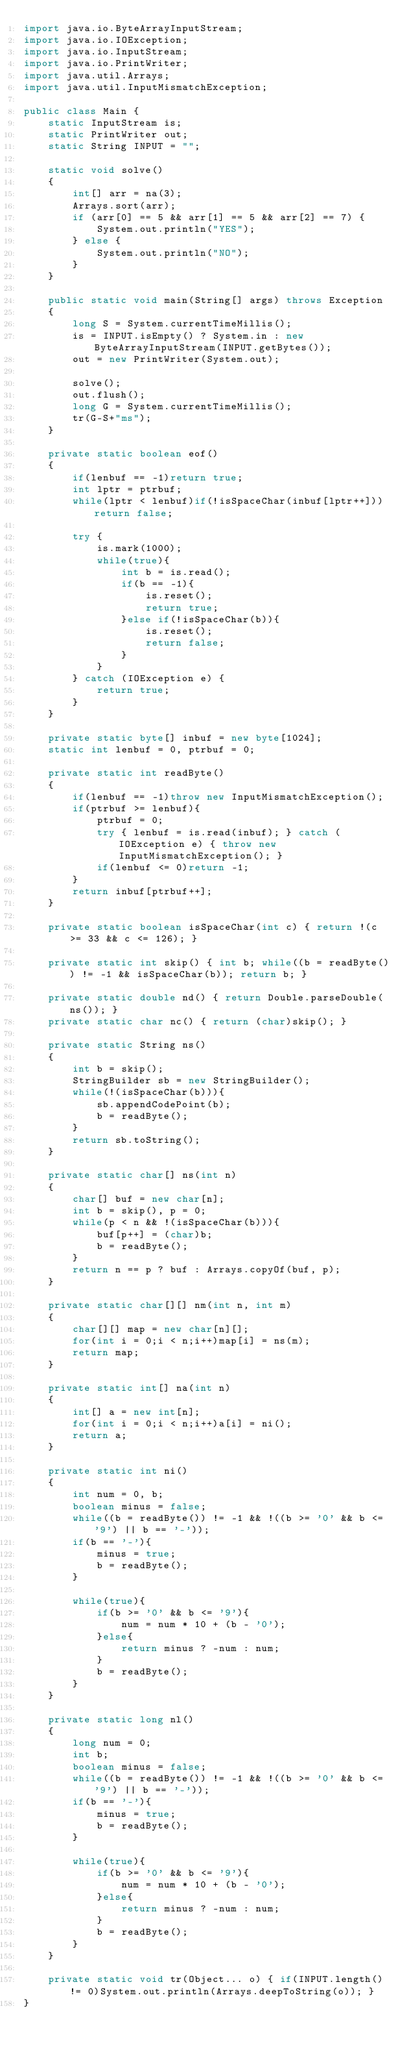Convert code to text. <code><loc_0><loc_0><loc_500><loc_500><_Java_>import java.io.ByteArrayInputStream;
import java.io.IOException;
import java.io.InputStream;
import java.io.PrintWriter;
import java.util.Arrays;
import java.util.InputMismatchException;

public class Main {
    static InputStream is;
    static PrintWriter out;
    static String INPUT = "";

    static void solve()
    {
        int[] arr = na(3);
        Arrays.sort(arr);
        if (arr[0] == 5 && arr[1] == 5 && arr[2] == 7) {
            System.out.println("YES");
        } else {
            System.out.println("NO");
        }
    }

    public static void main(String[] args) throws Exception
    {
        long S = System.currentTimeMillis();
        is = INPUT.isEmpty() ? System.in : new ByteArrayInputStream(INPUT.getBytes());
        out = new PrintWriter(System.out);

        solve();
        out.flush();
        long G = System.currentTimeMillis();
        tr(G-S+"ms");
    }

    private static boolean eof()
    {
        if(lenbuf == -1)return true;
        int lptr = ptrbuf;
        while(lptr < lenbuf)if(!isSpaceChar(inbuf[lptr++]))return false;

        try {
            is.mark(1000);
            while(true){
                int b = is.read();
                if(b == -1){
                    is.reset();
                    return true;
                }else if(!isSpaceChar(b)){
                    is.reset();
                    return false;
                }
            }
        } catch (IOException e) {
            return true;
        }
    }

    private static byte[] inbuf = new byte[1024];
    static int lenbuf = 0, ptrbuf = 0;

    private static int readByte()
    {
        if(lenbuf == -1)throw new InputMismatchException();
        if(ptrbuf >= lenbuf){
            ptrbuf = 0;
            try { lenbuf = is.read(inbuf); } catch (IOException e) { throw new InputMismatchException(); }
            if(lenbuf <= 0)return -1;
        }
        return inbuf[ptrbuf++];
    }

    private static boolean isSpaceChar(int c) { return !(c >= 33 && c <= 126); }

    private static int skip() { int b; while((b = readByte()) != -1 && isSpaceChar(b)); return b; }

    private static double nd() { return Double.parseDouble(ns()); }
    private static char nc() { return (char)skip(); }

    private static String ns()
    {
        int b = skip();
        StringBuilder sb = new StringBuilder();
        while(!(isSpaceChar(b))){
            sb.appendCodePoint(b);
            b = readByte();
        }
        return sb.toString();
    }

    private static char[] ns(int n)
    {
        char[] buf = new char[n];
        int b = skip(), p = 0;
        while(p < n && !(isSpaceChar(b))){
            buf[p++] = (char)b;
            b = readByte();
        }
        return n == p ? buf : Arrays.copyOf(buf, p);
    }

    private static char[][] nm(int n, int m)
    {
        char[][] map = new char[n][];
        for(int i = 0;i < n;i++)map[i] = ns(m);
        return map;
    }

    private static int[] na(int n)
    {
        int[] a = new int[n];
        for(int i = 0;i < n;i++)a[i] = ni();
        return a;
    }

    private static int ni()
    {
        int num = 0, b;
        boolean minus = false;
        while((b = readByte()) != -1 && !((b >= '0' && b <= '9') || b == '-'));
        if(b == '-'){
            minus = true;
            b = readByte();
        }

        while(true){
            if(b >= '0' && b <= '9'){
                num = num * 10 + (b - '0');
            }else{
                return minus ? -num : num;
            }
            b = readByte();
        }
    }

    private static long nl()
    {
        long num = 0;
        int b;
        boolean minus = false;
        while((b = readByte()) != -1 && !((b >= '0' && b <= '9') || b == '-'));
        if(b == '-'){
            minus = true;
            b = readByte();
        }

        while(true){
            if(b >= '0' && b <= '9'){
                num = num * 10 + (b - '0');
            }else{
                return minus ? -num : num;
            }
            b = readByte();
        }
    }

    private static void tr(Object... o) { if(INPUT.length() != 0)System.out.println(Arrays.deepToString(o)); }
}

</code> 